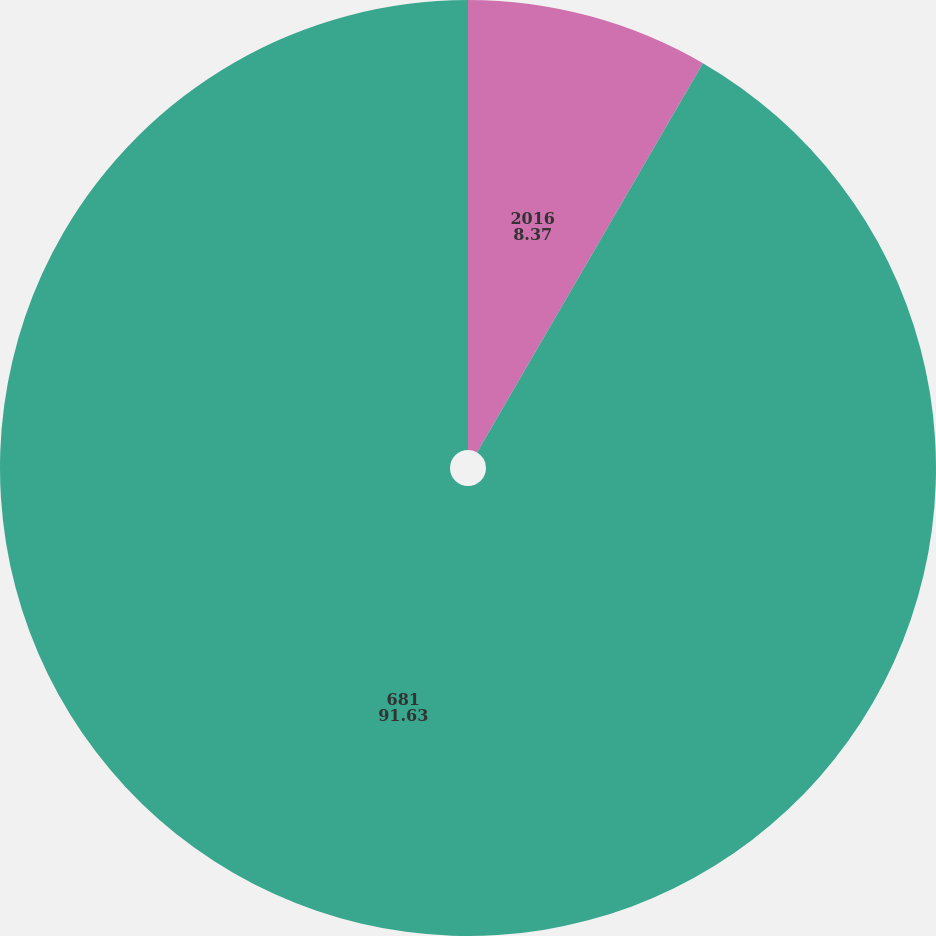Convert chart to OTSL. <chart><loc_0><loc_0><loc_500><loc_500><pie_chart><fcel>2016<fcel>681<nl><fcel>8.37%<fcel>91.63%<nl></chart> 